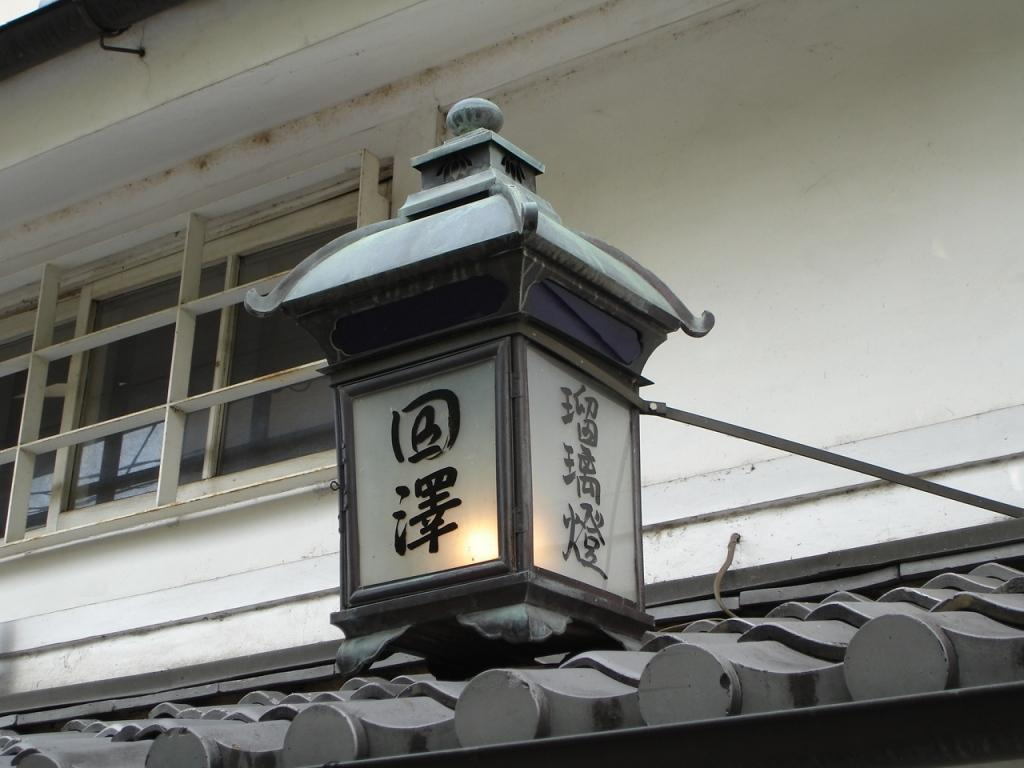What is located on the roof in the image? There is a lamp on the roof in the image. What can be seen behind the lamp? There is a window behind the lamp. What is beside the window? There is a wall beside the window. How many feet are visible in the image? There are no feet visible in the image. What type of bulb is used in the lamp in the image? The image does not provide information about the type of bulb used in the lamp. 